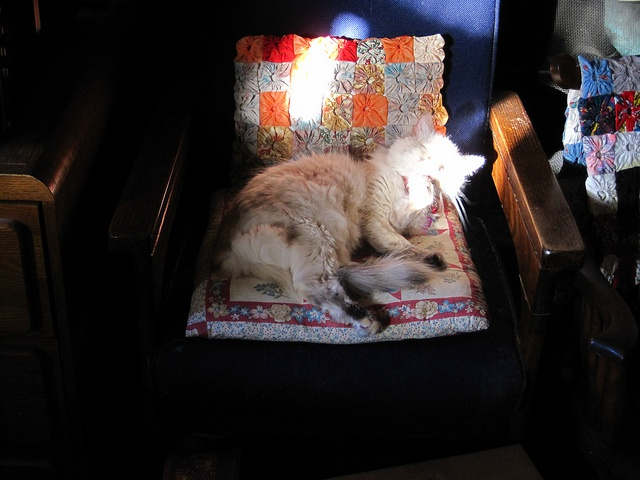Describe the objects in this image and their specific colors. I can see chair in black, darkgray, and gray tones and cat in black, gray, darkgray, and white tones in this image. 